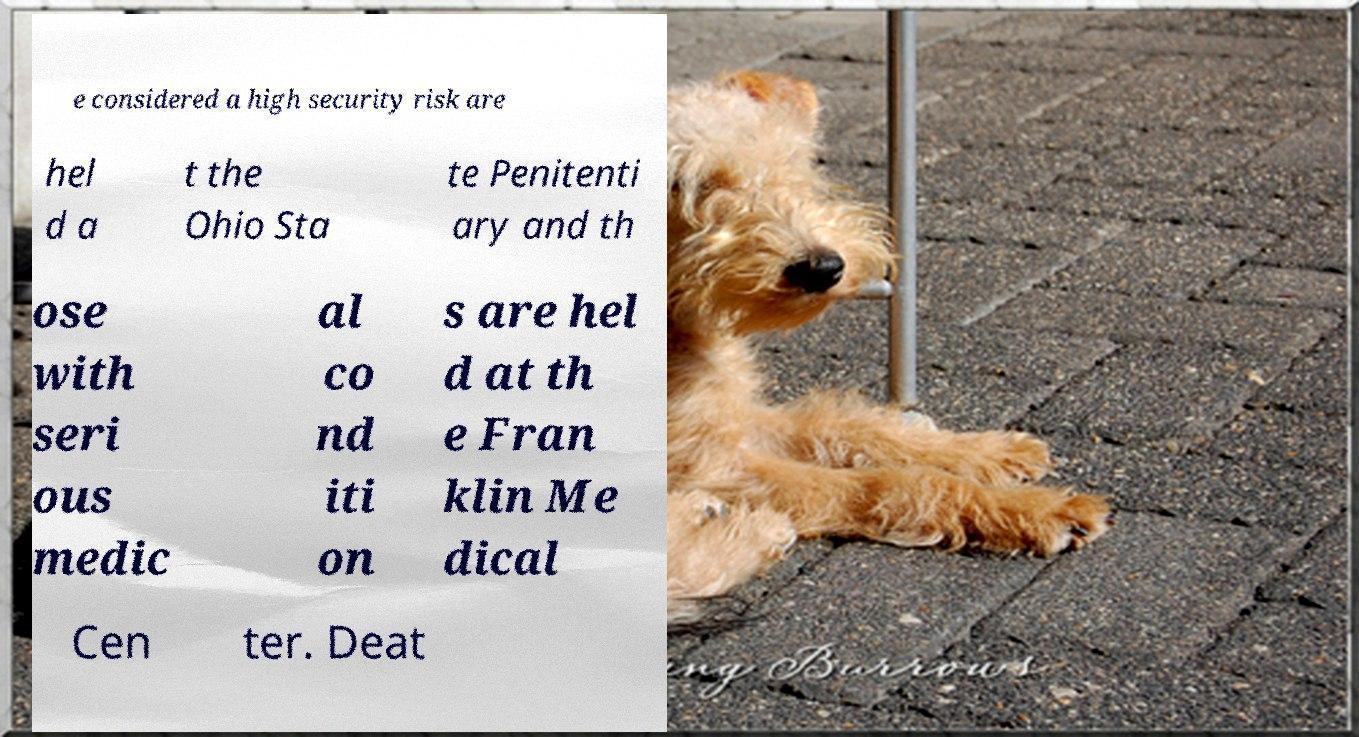I need the written content from this picture converted into text. Can you do that? e considered a high security risk are hel d a t the Ohio Sta te Penitenti ary and th ose with seri ous medic al co nd iti on s are hel d at th e Fran klin Me dical Cen ter. Deat 